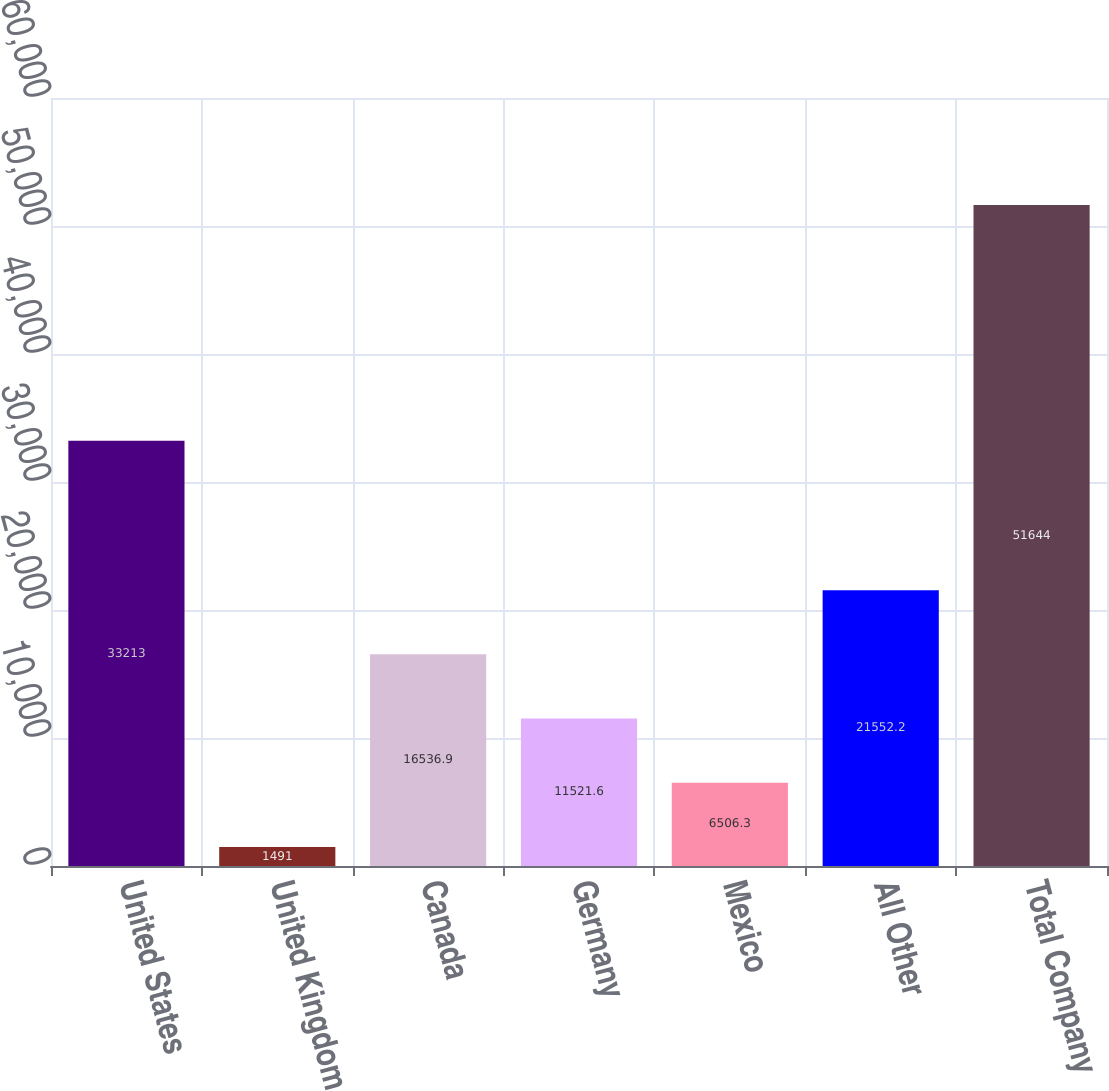<chart> <loc_0><loc_0><loc_500><loc_500><bar_chart><fcel>United States<fcel>United Kingdom<fcel>Canada<fcel>Germany<fcel>Mexico<fcel>All Other<fcel>Total Company<nl><fcel>33213<fcel>1491<fcel>16536.9<fcel>11521.6<fcel>6506.3<fcel>21552.2<fcel>51644<nl></chart> 